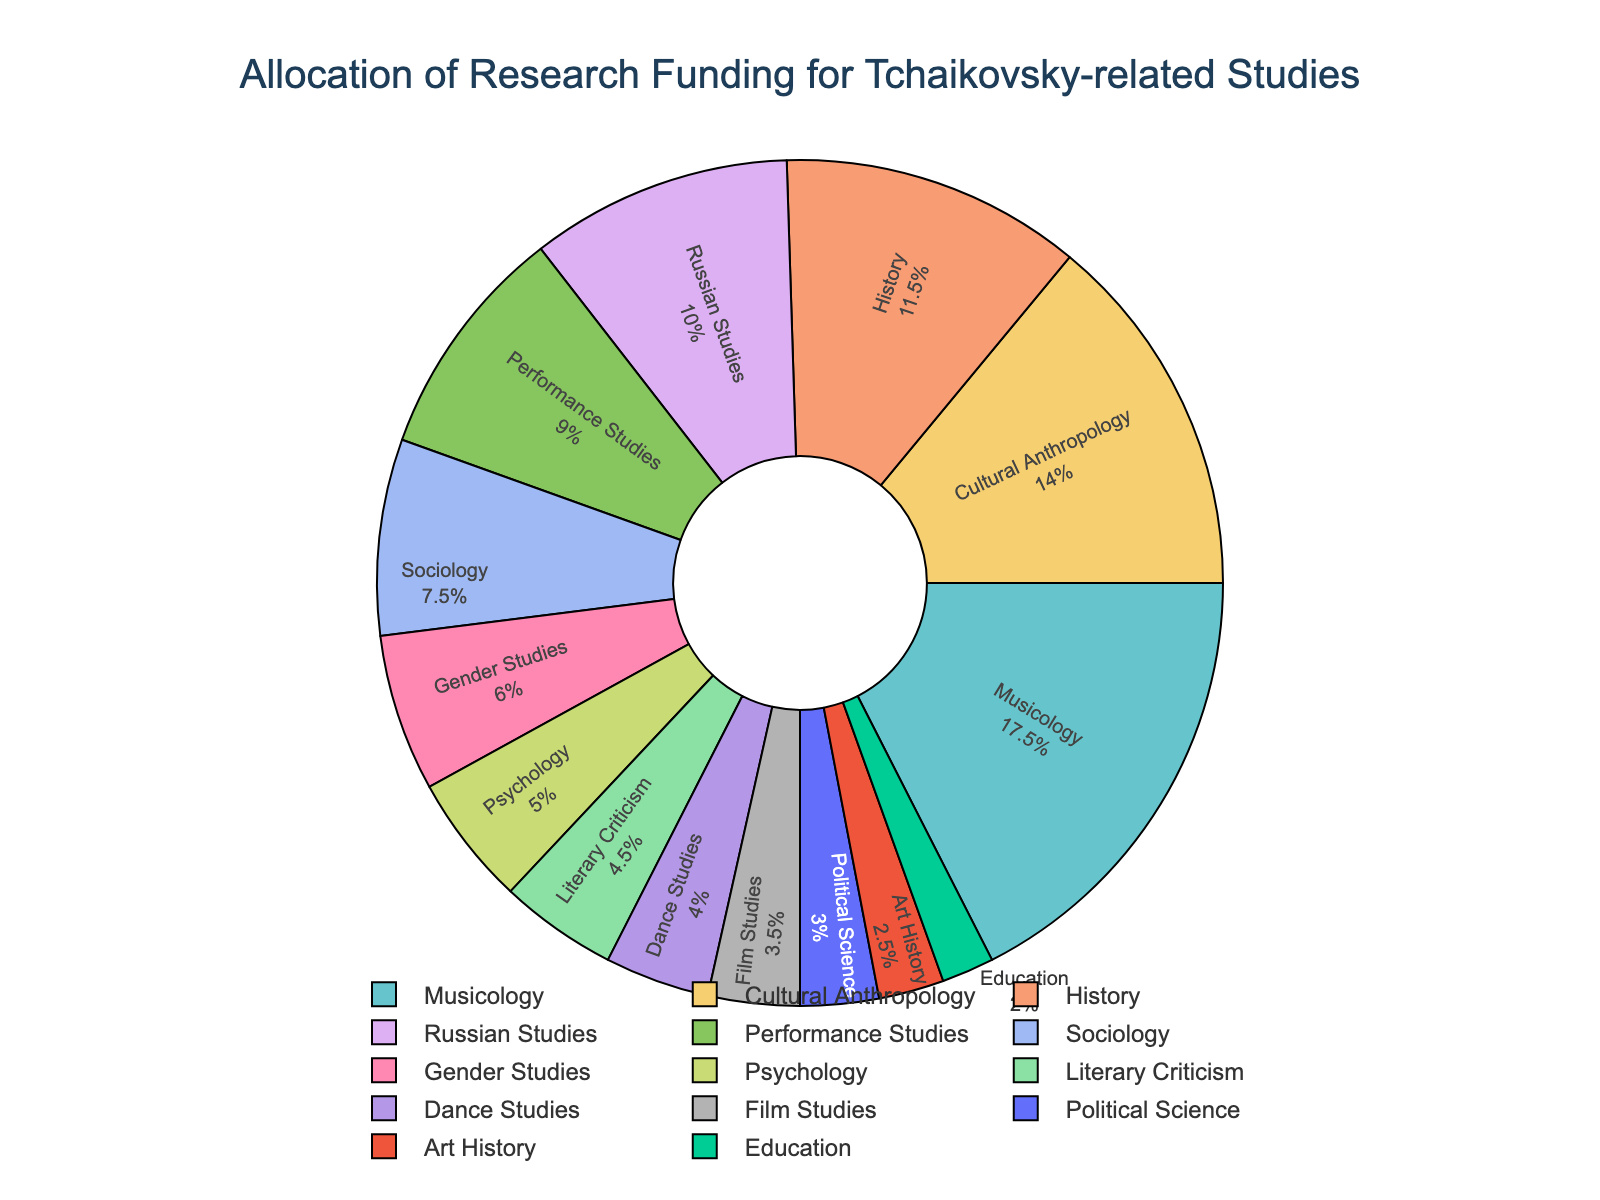What is the percentage allocation for Musicology? Find the section labeled "Musicology" and note the percent value inside it.
Answer: 22.72% Which discipline received more funding, Cultural Anthropology or Russian Studies? Compare the funding allocation percentages of "Cultural Anthropology" and "Russian Studies". "Cultural Anthropology" has a larger slice.
Answer: Cultural Anthropology How much more funding did Musicology receive compared to Film Studies? Locate the values for "Musicology" (350000) and "Film Studies" (70000). Subtract Film Studies' funding from Musicology's funding: 350000 - 70000 = 280000.
Answer: 280000 What is the combined funding allocation for History and Sociology? Locate the values for "History" (230000) and "Sociology" (150000). Add them together: 230000 + 150000 = 380000.
Answer: 380000 Which discipline received the least amount of funding and what percentage does it represent? Identify the smallest slice in the pie chart; the label "Education" has the smallest size/percentage.
Answer: Education, 2.6% Compare the funding amounts for Performance Studies and Gender Studies. Which one is higher? Compare the slices for "Performance Studies" (180000) and "Gender Studies" (120000). "Performance Studies" is higher.
Answer: Performance Studies What percentage of the total funding did the top three disciplines receive? Identify the top three disciplines by funding: Musicology, Cultural Anthropology, and History. Sum their funding: 350000 + 280000 + 230000 = 860000. Calculate the total funding, then compute the percentage: (860000 / 2000000) * 100 ≈ 43%.
Answer: 43% How does the allocation for Literary Criticism compare visually with Dance Studies? Compare the size/length of the slices labeled "Literary Criticism" and "Dance Studies". "Literary Criticism" appears slightly larger than "Dance Studies".
Answer: Literary Criticism is larger What is the difference in funding between the largest and smallest funded disciplines? Identify the largest funded (Musicology: 350000) and smallest funded (Education: 40000) disciplines. Subtract the smallest from the largest: 350000 - 40000 = 310000.
Answer: 310000 